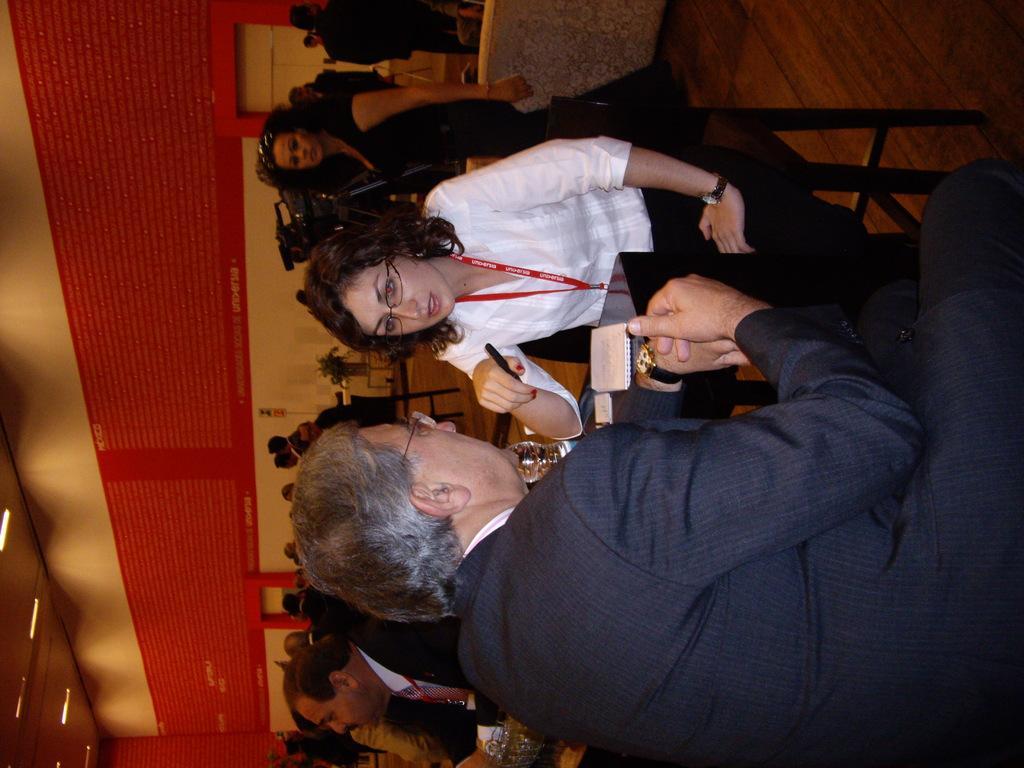Describe this image in one or two sentences. In this image we can see a man and a woman sitting on the chairs beside a table containing a book and a glass on it. In that a woman is holding a pen. On the backside we can see a group of people sitting on the chairs and some people standing. We can also see a camera, a plant in a pot, a board on a wall with some text on it and a roof with some ceiling lights. 